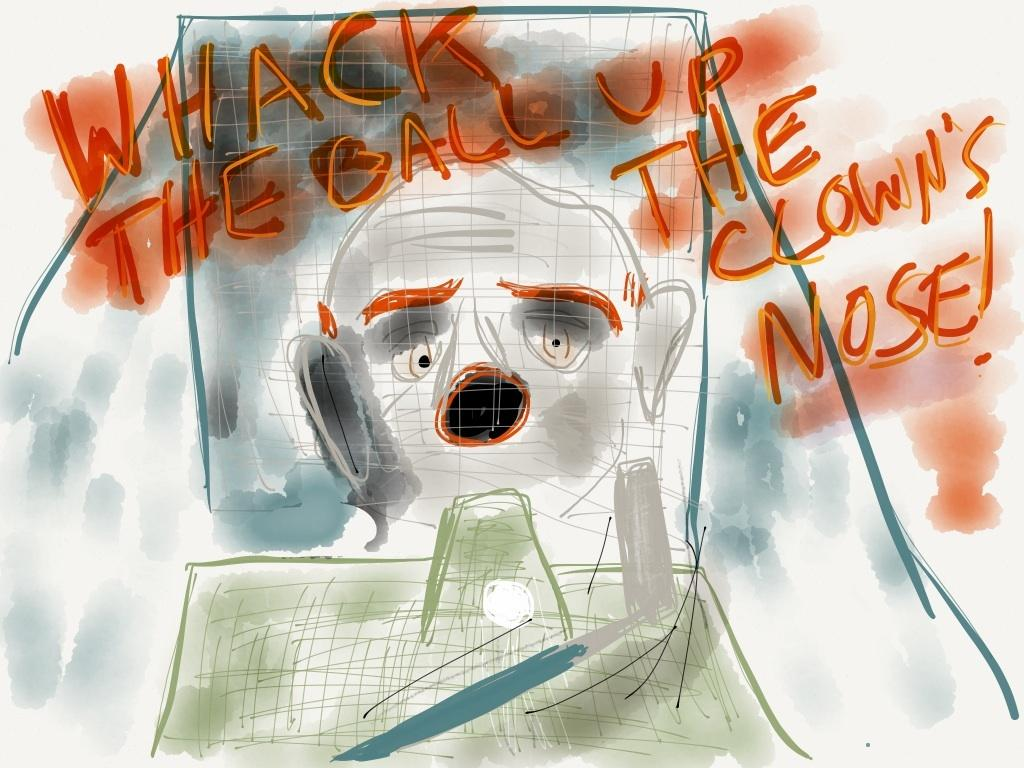What is the main subject of the image? There is a painting in the image. Can you describe the painting? The painting has text written on it. How does the painting contribute to pollution in the image? The painting does not contribute to pollution in the image, as it is an inanimate object and not capable of producing pollution. 